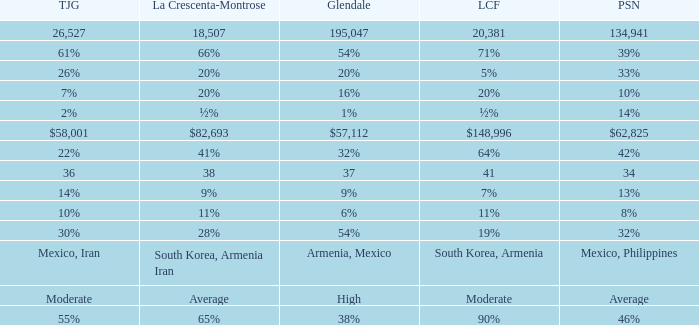What is the value for la crescenta-montrose when glendale is $57,112? $82,693. 